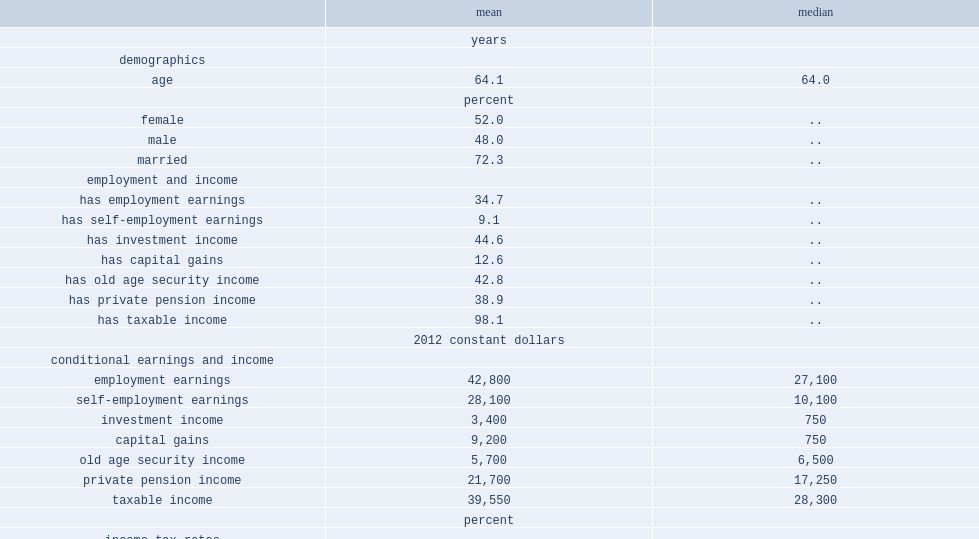What is the average age of individuals? 64.1. What is the percentage of women in individuals? 52.0. What is the percentage of being married in individuals? 72.3. What is the percentage of individuals with labour earnings from employment? 34.7. What is the percentage of individuals with labour earnings from self-employment? 9.1. What is the percentage of individuals with investment income? 44.6. What is the percentage of individuals with oas income? 42.8. What is the percentage of individuals with private pension income? 38.9. What is the mean value of taxable income, conditional on these values being strictly positive? 39550.0. What is the median value of taxable income, conditional on these values being strictly positive? 28300.0. Using ctacs, what is the mean value of the predicted marginal income tax rate? 22.1. Using ctacs, what is the median value of the predicted marginal income tax rate? 23.6. Can you parse all the data within this table? {'header': ['', 'mean', 'median'], 'rows': [['', 'years', ''], ['demographics', '', ''], ['age', '64.1', '64.0'], ['', 'percent', ''], ['female', '52.0', '..'], ['male', '48.0', '..'], ['married', '72.3', '..'], ['employment and income', '', ''], ['has employment earnings', '34.7', '..'], ['has self-employment earnings', '9.1', '..'], ['has investment income', '44.6', '..'], ['has capital gains', '12.6', '..'], ['has old age security income', '42.8', '..'], ['has private pension income', '38.9', '..'], ['has taxable income', '98.1', '..'], ['', '2012 constant dollars', ''], ['conditional earnings and income', '', ''], ['employment earnings', '42,800', '27,100'], ['self-employment earnings', '28,100', '10,100'], ['investment income', '3,400', '750'], ['capital gains', '9,200', '750'], ['old age security income', '5,700', '6,500'], ['private pension income', '21,700', '17,250'], ['taxable income', '39,550', '28,300'], ['', 'percent', ''], ['income-tax rates', '', ''], ['predicted marginal income tax rate', '22.1', '23.6'], ['predicted average income tax rate', '11.4', '13.2']]} 